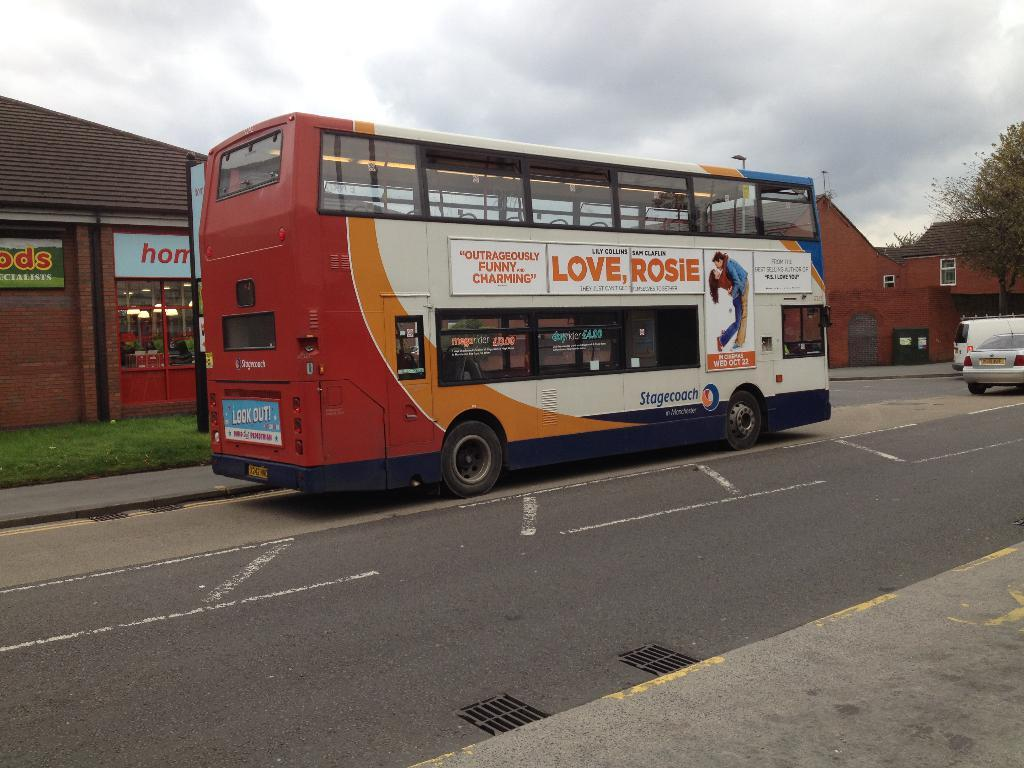What is the main subject of the image? The main subject of the image is a bus moving on the road. What else can be seen moving on the road in the image? There are other vehicles moving on the right side of the road in the image. What can be seen in the background of the image? There are buildings and trees in the background of the image. How would you describe the weather in the image? The sky is cloudy in the image, suggesting overcast or potentially rainy weather. What type of mass is being taught in the image? There is no indication of any learning or teaching taking place in the image, as it primarily features a bus and other vehicles moving on the road. Can you describe the lamp that is illuminating the scene in the image? There is no lamp present in the image; the scene is illuminated by natural light from the sky. 